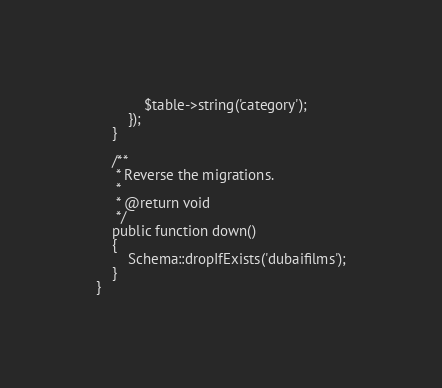<code> <loc_0><loc_0><loc_500><loc_500><_PHP_>            $table->string('category');
        });
    }

    /**
     * Reverse the migrations.
     *
     * @return void
     */
    public function down()
    {
        Schema::dropIfExists('dubaifilms');
    }
}
</code> 